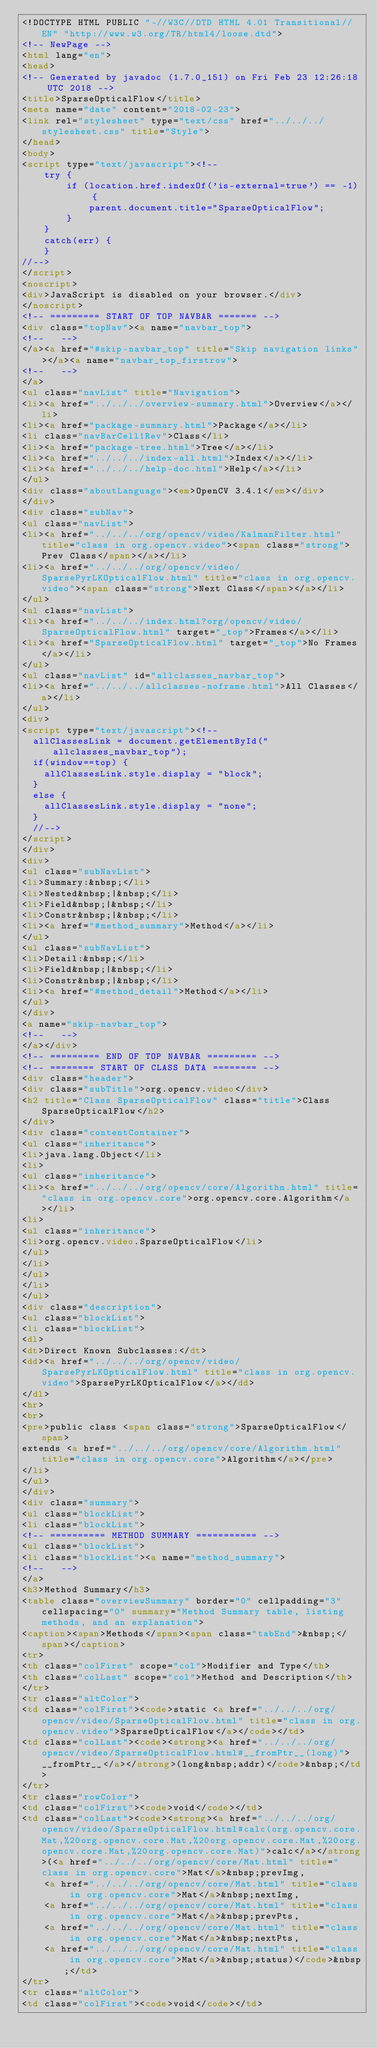Convert code to text. <code><loc_0><loc_0><loc_500><loc_500><_HTML_><!DOCTYPE HTML PUBLIC "-//W3C//DTD HTML 4.01 Transitional//EN" "http://www.w3.org/TR/html4/loose.dtd">
<!-- NewPage -->
<html lang="en">
<head>
<!-- Generated by javadoc (1.7.0_151) on Fri Feb 23 12:26:18 UTC 2018 -->
<title>SparseOpticalFlow</title>
<meta name="date" content="2018-02-23">
<link rel="stylesheet" type="text/css" href="../../../stylesheet.css" title="Style">
</head>
<body>
<script type="text/javascript"><!--
    try {
        if (location.href.indexOf('is-external=true') == -1) {
            parent.document.title="SparseOpticalFlow";
        }
    }
    catch(err) {
    }
//-->
</script>
<noscript>
<div>JavaScript is disabled on your browser.</div>
</noscript>
<!-- ========= START OF TOP NAVBAR ======= -->
<div class="topNav"><a name="navbar_top">
<!--   -->
</a><a href="#skip-navbar_top" title="Skip navigation links"></a><a name="navbar_top_firstrow">
<!--   -->
</a>
<ul class="navList" title="Navigation">
<li><a href="../../../overview-summary.html">Overview</a></li>
<li><a href="package-summary.html">Package</a></li>
<li class="navBarCell1Rev">Class</li>
<li><a href="package-tree.html">Tree</a></li>
<li><a href="../../../index-all.html">Index</a></li>
<li><a href="../../../help-doc.html">Help</a></li>
</ul>
<div class="aboutLanguage"><em>OpenCV 3.4.1</em></div>
</div>
<div class="subNav">
<ul class="navList">
<li><a href="../../../org/opencv/video/KalmanFilter.html" title="class in org.opencv.video"><span class="strong">Prev Class</span></a></li>
<li><a href="../../../org/opencv/video/SparsePyrLKOpticalFlow.html" title="class in org.opencv.video"><span class="strong">Next Class</span></a></li>
</ul>
<ul class="navList">
<li><a href="../../../index.html?org/opencv/video/SparseOpticalFlow.html" target="_top">Frames</a></li>
<li><a href="SparseOpticalFlow.html" target="_top">No Frames</a></li>
</ul>
<ul class="navList" id="allclasses_navbar_top">
<li><a href="../../../allclasses-noframe.html">All Classes</a></li>
</ul>
<div>
<script type="text/javascript"><!--
  allClassesLink = document.getElementById("allclasses_navbar_top");
  if(window==top) {
    allClassesLink.style.display = "block";
  }
  else {
    allClassesLink.style.display = "none";
  }
  //-->
</script>
</div>
<div>
<ul class="subNavList">
<li>Summary:&nbsp;</li>
<li>Nested&nbsp;|&nbsp;</li>
<li>Field&nbsp;|&nbsp;</li>
<li>Constr&nbsp;|&nbsp;</li>
<li><a href="#method_summary">Method</a></li>
</ul>
<ul class="subNavList">
<li>Detail:&nbsp;</li>
<li>Field&nbsp;|&nbsp;</li>
<li>Constr&nbsp;|&nbsp;</li>
<li><a href="#method_detail">Method</a></li>
</ul>
</div>
<a name="skip-navbar_top">
<!--   -->
</a></div>
<!-- ========= END OF TOP NAVBAR ========= -->
<!-- ======== START OF CLASS DATA ======== -->
<div class="header">
<div class="subTitle">org.opencv.video</div>
<h2 title="Class SparseOpticalFlow" class="title">Class SparseOpticalFlow</h2>
</div>
<div class="contentContainer">
<ul class="inheritance">
<li>java.lang.Object</li>
<li>
<ul class="inheritance">
<li><a href="../../../org/opencv/core/Algorithm.html" title="class in org.opencv.core">org.opencv.core.Algorithm</a></li>
<li>
<ul class="inheritance">
<li>org.opencv.video.SparseOpticalFlow</li>
</ul>
</li>
</ul>
</li>
</ul>
<div class="description">
<ul class="blockList">
<li class="blockList">
<dl>
<dt>Direct Known Subclasses:</dt>
<dd><a href="../../../org/opencv/video/SparsePyrLKOpticalFlow.html" title="class in org.opencv.video">SparsePyrLKOpticalFlow</a></dd>
</dl>
<hr>
<br>
<pre>public class <span class="strong">SparseOpticalFlow</span>
extends <a href="../../../org/opencv/core/Algorithm.html" title="class in org.opencv.core">Algorithm</a></pre>
</li>
</ul>
</div>
<div class="summary">
<ul class="blockList">
<li class="blockList">
<!-- ========== METHOD SUMMARY =========== -->
<ul class="blockList">
<li class="blockList"><a name="method_summary">
<!--   -->
</a>
<h3>Method Summary</h3>
<table class="overviewSummary" border="0" cellpadding="3" cellspacing="0" summary="Method Summary table, listing methods, and an explanation">
<caption><span>Methods</span><span class="tabEnd">&nbsp;</span></caption>
<tr>
<th class="colFirst" scope="col">Modifier and Type</th>
<th class="colLast" scope="col">Method and Description</th>
</tr>
<tr class="altColor">
<td class="colFirst"><code>static <a href="../../../org/opencv/video/SparseOpticalFlow.html" title="class in org.opencv.video">SparseOpticalFlow</a></code></td>
<td class="colLast"><code><strong><a href="../../../org/opencv/video/SparseOpticalFlow.html#__fromPtr__(long)">__fromPtr__</a></strong>(long&nbsp;addr)</code>&nbsp;</td>
</tr>
<tr class="rowColor">
<td class="colFirst"><code>void</code></td>
<td class="colLast"><code><strong><a href="../../../org/opencv/video/SparseOpticalFlow.html#calc(org.opencv.core.Mat,%20org.opencv.core.Mat,%20org.opencv.core.Mat,%20org.opencv.core.Mat,%20org.opencv.core.Mat)">calc</a></strong>(<a href="../../../org/opencv/core/Mat.html" title="class in org.opencv.core">Mat</a>&nbsp;prevImg,
    <a href="../../../org/opencv/core/Mat.html" title="class in org.opencv.core">Mat</a>&nbsp;nextImg,
    <a href="../../../org/opencv/core/Mat.html" title="class in org.opencv.core">Mat</a>&nbsp;prevPts,
    <a href="../../../org/opencv/core/Mat.html" title="class in org.opencv.core">Mat</a>&nbsp;nextPts,
    <a href="../../../org/opencv/core/Mat.html" title="class in org.opencv.core">Mat</a>&nbsp;status)</code>&nbsp;</td>
</tr>
<tr class="altColor">
<td class="colFirst"><code>void</code></td></code> 